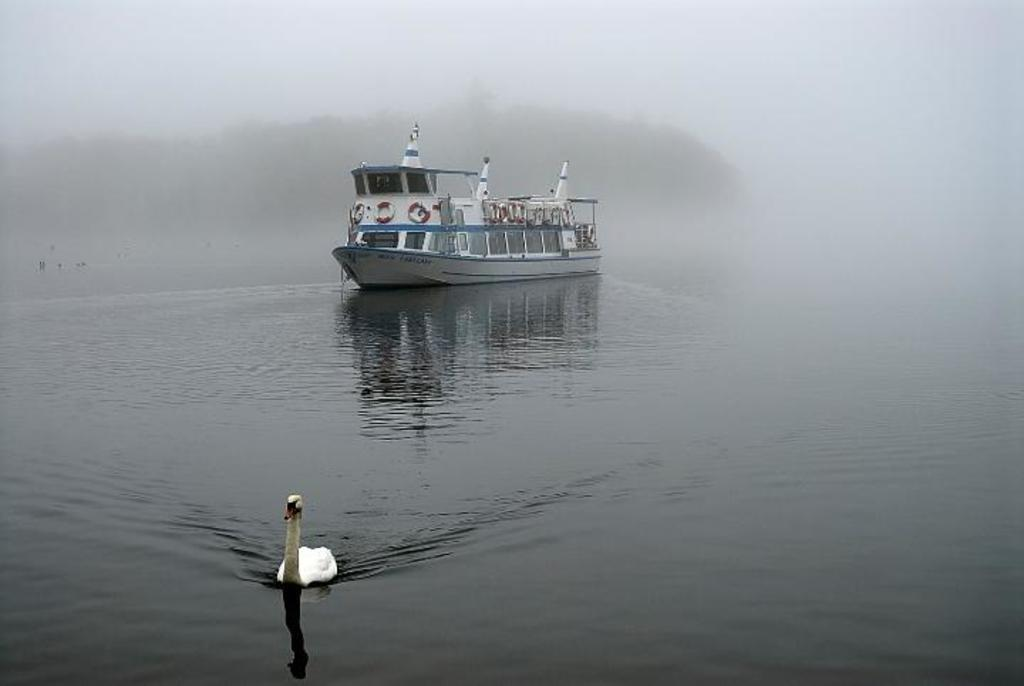What is the main subject in the image? There is a boat in the image. What is the color of the boat? The boat is white and blue in color. Where is the boat located in relation to the water? The boat is on the surface of the water. What other living creature can be seen in the image? There is a bird in the image. What is visible in the background of the image? There is fog and the sky visible in the background of the image. How many pears are visible on the boat in the image? There are no pears present in the image. Can you see any snails crawling on the boat in the image? There are no snails visible on the boat in the image. 